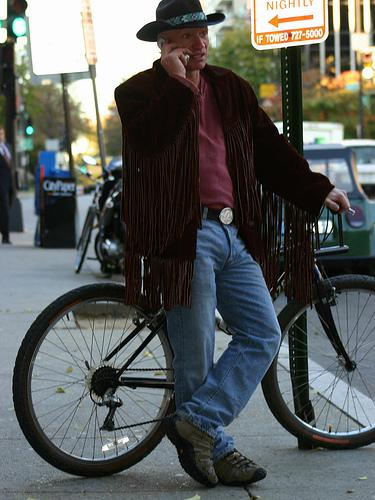What is the footwear worn by the man called, and what are its colors? The man is wearing a pair of brown and black hiking shoes. By analyzing the image, can you tell the possible age group of the man? The man appears to be an older man, suggesting he might be in the middle age to senior age group. List down four objects that are present in the background. Street sign on a pole, newspaper boxes, traffic lights displaying green lights, and a part of a green tree. What is the color and decoration detail on the man's cowboy hat? The cowboy hat is black, and it has blue decorations on it. Point out any visible means of communication the man is using. The man is talking on a silver cellphone, held in his hand near his face. State the man's leaning direction and what he is leaning on. The man is leaning towards his left against a black bicycle. Describe the type of bicycle and its location in relation to the man. There is a black bicycle parked behind the man on a sidewalk, with the man leaning against it. Estimate the number of items associated with the man in the image. There are around 18 to 20 items associated with the man in the image. Explain the kind of outfit the man in the image is wearing. The man is wearing a western attire, including a black cowboy hat with blue decorations, a red shirt, a unique brown coat with tassles, jeans, a black belt with a large round buckle, and a pair of brown and black hiking shoes. Mention any distinctive feature of the man's coat. The man's coat is brown, and it has long brown strings or tassels hanging from it. 